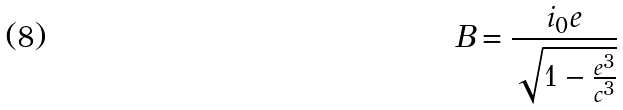Convert formula to latex. <formula><loc_0><loc_0><loc_500><loc_500>B = \frac { i _ { 0 } e } { \sqrt { 1 - \frac { e ^ { 3 } } { c ^ { 3 } } } }</formula> 